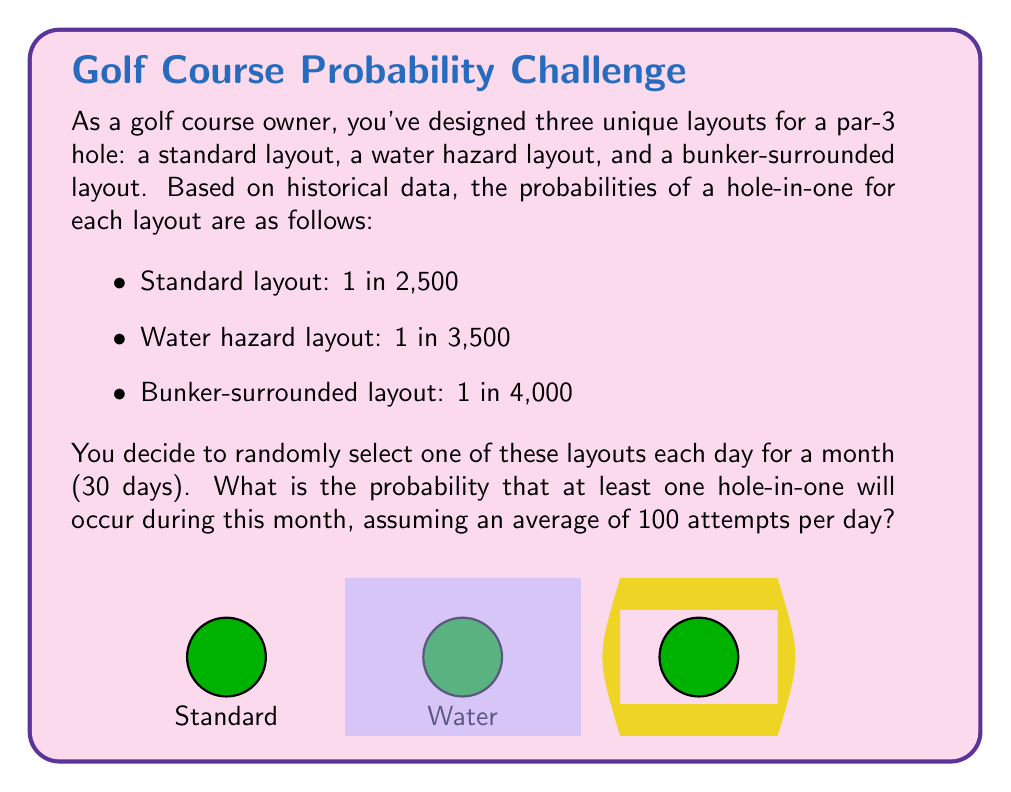Teach me how to tackle this problem. Let's approach this step-by-step:

1) First, we need to calculate the probability of a hole-in-one for each layout per day:

   Standard: $P_s = 1 - (1 - \frac{1}{2500})^{100} = 1 - (0.9996)^{100} \approx 0.03921$
   Water: $P_w = 1 - (1 - \frac{1}{3500})^{100} = 1 - (0.9997143)^{100} \approx 0.02817$
   Bunker: $P_b = 1 - (1 - \frac{1}{4000})^{100} = 1 - (0.99975)^{100} \approx 0.02469$

2) The probability of no hole-in-one on a given day is the average of these probabilities:

   $P_{no} = \frac{(1-P_s) + (1-P_w) + (1-P_b)}{3} = \frac{0.96079 + 0.97183 + 0.97531}{3} \approx 0.96931$

3) The probability of at least one hole-in-one in 30 days is the complement of the probability of no hole-in-ones in 30 days:

   $P_{at least one} = 1 - P_{no}^{30} = 1 - (0.96931)^{30} \approx 0.59735$

Therefore, the probability of at least one hole-in-one occurring during the month is approximately 0.59735 or 59.735%.
Answer: $\approx 0.59735$ or $59.735\%$ 